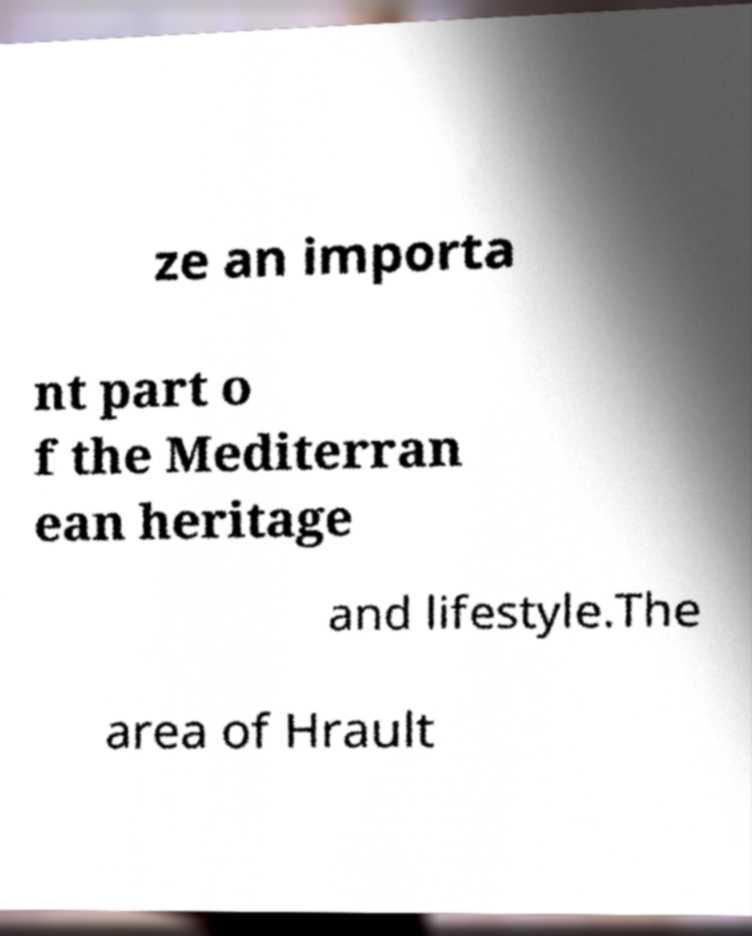Could you extract and type out the text from this image? ze an importa nt part o f the Mediterran ean heritage and lifestyle.The area of Hrault 